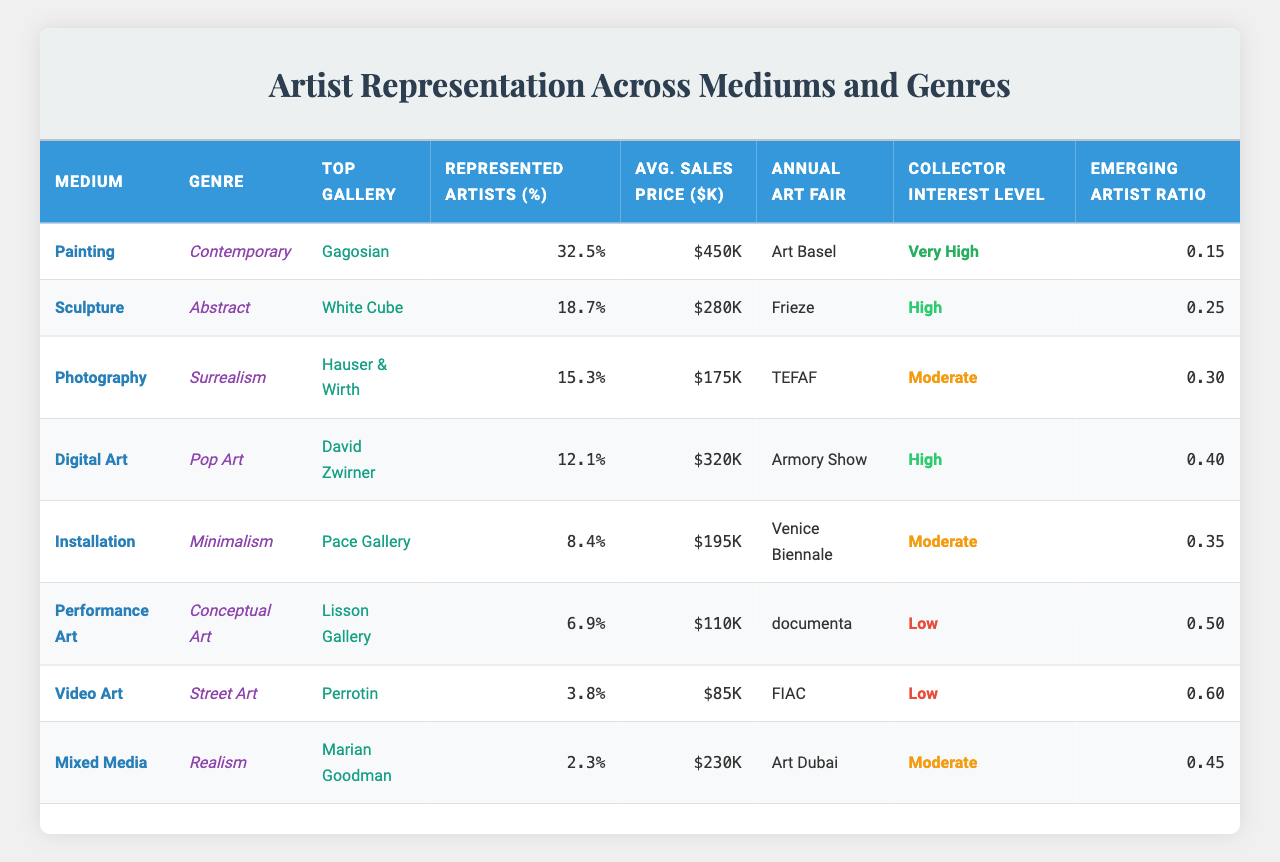What is the medium with the highest percentage of represented artists? The table lists the "Represented Artists (%)" for each medium. The highest percentage is 32.5%, which corresponds to "Painting."
Answer: Painting Which genre has the lowest average sales price? By looking at the "Avg. Sales Price ($K)" column, "Video Art" has the lowest average sales price of $85K.
Answer: Video Art How many mediums have a collector interest level classified as 'Low'? The table shows that "Performance Art," "Video Art," and "Mixed Media" have a collector interest level of 'Low.' This is a total of three mediums.
Answer: 3 What is the average represented artist percentage across all mediums? To find the average, sum all percentages: 32.5 + 18.7 + 15.3 + 12.1 + 8.4 + 6.9 + 3.8 + 2.3 = 99.0. There are 8 mediums, so the average is 99.0 / 8 = 12.375.
Answer: 12.4% Is there a medium associated with 'Very High' collector interest? Checking the "Collector Interest Level" column, "Painting" has a collector interest level of 'Very High.'
Answer: Yes What medium has the highest average sales price and what is that price? The "Avg. Sales Price ($K)" column shows "Painting" with the highest average sales price of $450K.
Answer: Painting, $450K If we compare the emerging artist ratios of Sculpture and Digital Art, which has a higher ratio? The "Emerging Artist Ratio" for "Sculpture" is 0.25 and for "Digital Art" is 0.40. Since 0.40 > 0.25, "Digital Art" has the higher ratio.
Answer: Digital Art What percentage of represented artists in Mixed Media exceeds 10%? The only Medum that exceeds 10% in the "Represented Artists (%)" column is "Mixed Media" with 2.3%, therefore no, it does not exceed 10%.
Answer: No How does the average sales price of Sculpture compare with the average of Digital Art and Installation combined? The average sales price of Sculpture is $280K; for Digital Art and Installation, it's ($320K + $195K) / 2 = $257.5K. $280K is greater than $257.5K, so Sculpture is higher.
Answer: Higher What is the total count of art fairs mentioned for each medium? Each medium is associated with one annual art fair as listed in the "Annual Art Fair" column, totaling 8 different art fairs across the mediums.
Answer: 8 Is 'Conceptual Art' represented in the category of 'Performance Art'? Looking at the table, 'Conceptual Art' is not listed under the "Performance Art" medium. Therefore, it does not represent 'Performance Art.'
Answer: No 